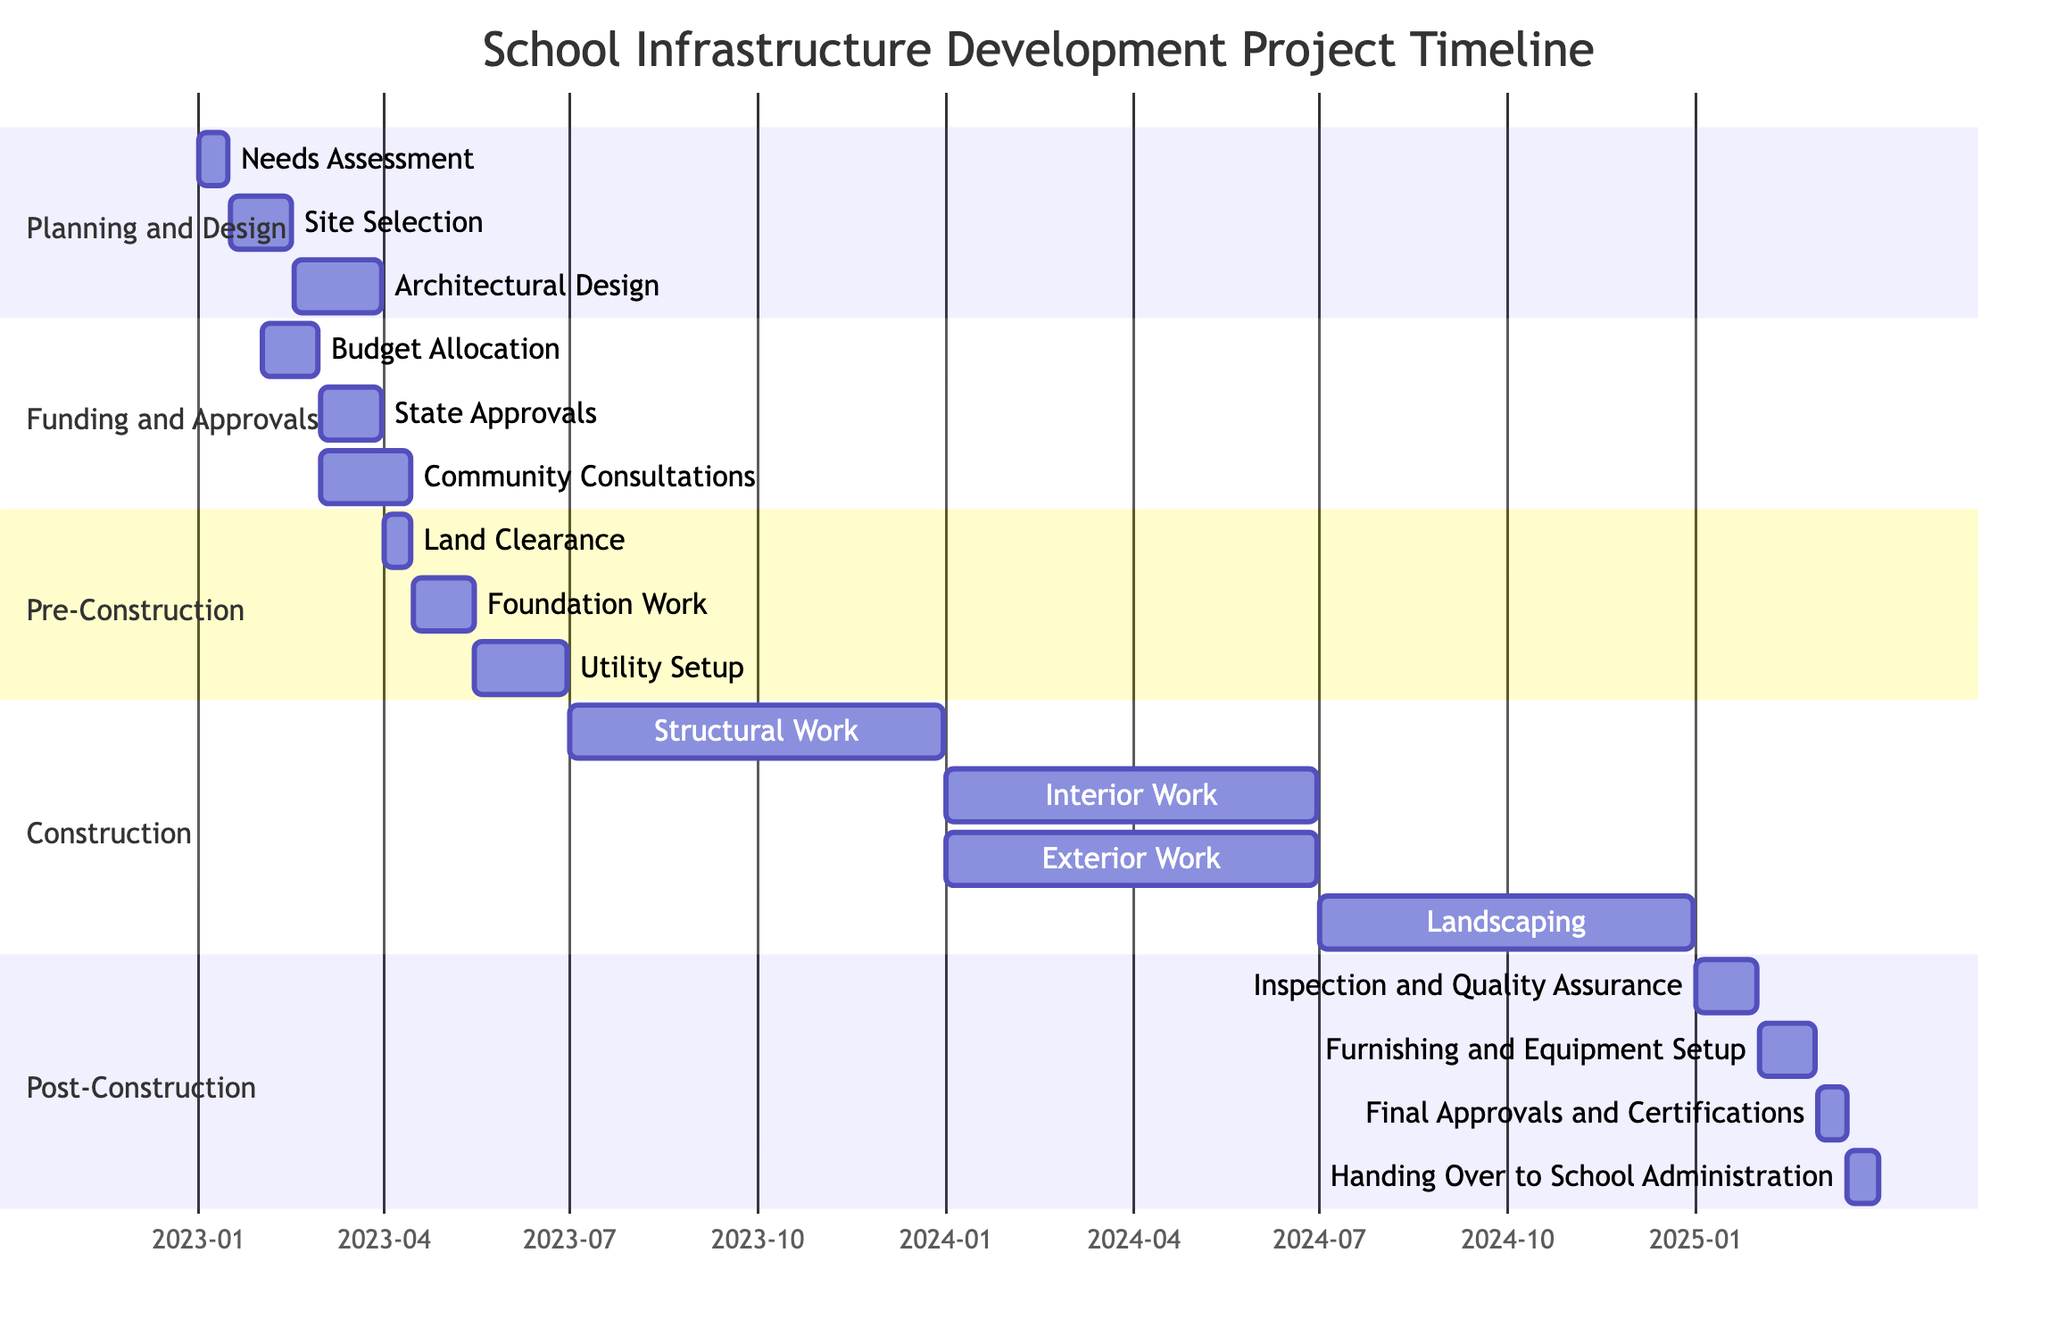What is the duration of the Planning and Design phase? The Planning and Design phase starts on January 1, 2023, and ends on March 31, 2023. To find the duration, calculate the difference: from January 1 to March 31 is exactly 3 months.
Answer: 3 months Which task starts after Budget Allocation? Looking at the Funding and Approvals section, Budget Allocation ends on February 28, 2023. The next task is State Approvals, which starts on March 1, 2023.
Answer: State Approvals How many tasks are there in the Construction phase? The Construction phase is outlined with four main tasks: Structural Work, Interior Work, Exterior Work, and Landscaping. Therefore, count these tasks to get the total.
Answer: 4 tasks What is the overlap between the Architectural Design and State Approvals tasks? Architectural Design starts on February 16, 2023, and ends on March 31, 2023. State Approvals starts on March 1, 2023, and ends on March 31, 2023. The overlap exists from March 1 to March 31, 2023.
Answer: 31 days When does the Landscaping task start? Upon examining the Construction phase, Landscaping is listed with a start date of July 1, 2024.
Answer: July 1, 2024 What is the end date for the Utility Setup task? In the Pre-Construction section, Utility Setup is specified, which ends on June 30, 2023.
Answer: June 30, 2023 Which phase has community consultations? In the Funding and Approvals section, Community Consultations is listed as a task, indicating that it falls under this phase.
Answer: Funding and Approvals What is the total length of the Post-Construction phase? The Post-Construction phase runs from January 1, 2025, to March 31, 2025. To find the length, count the months: January, February, and March, which totals 3 months.
Answer: 3 months 